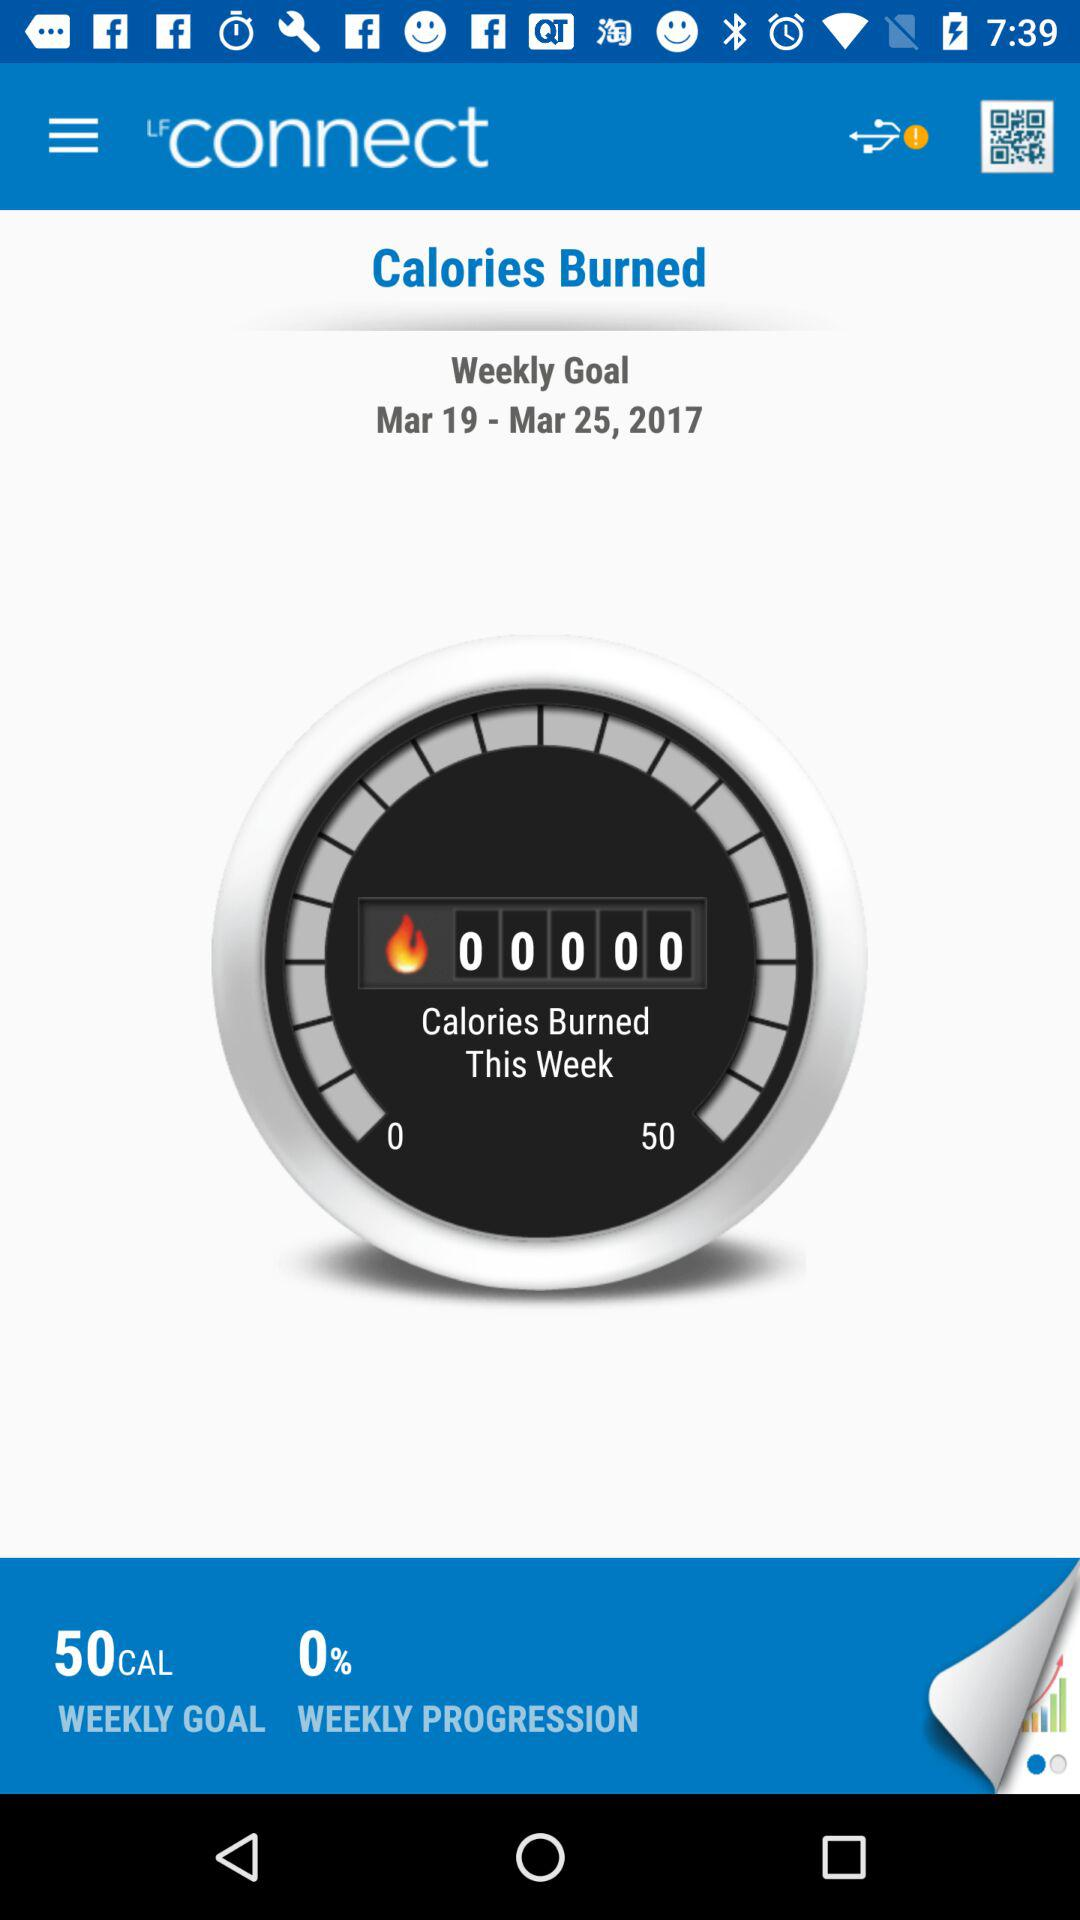What is the weekly goal date for calories burned? The weekly goal date for calories burned is from March 19, 2017 to March 25, 2017. 